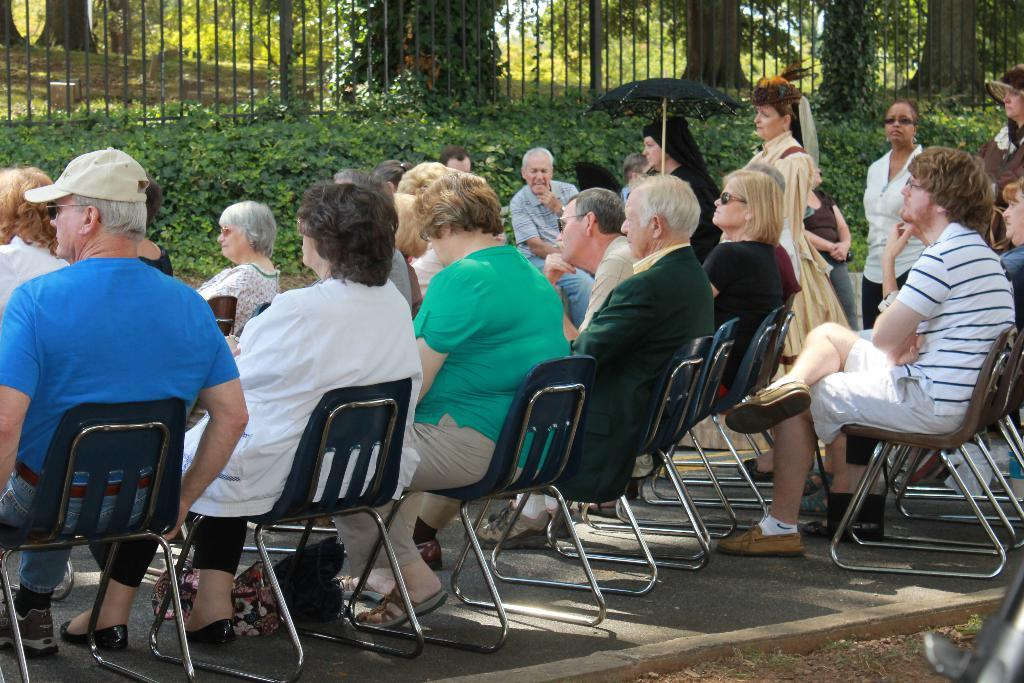How many people are in the image? There is a group of persons in the image. What are the persons doing in the image? The persons are sitting on a chair. What can be seen in the background of the image? There are trees in the background of the image. What type of knife is being used by the persons in the image? There is no knife present in the image. How many bricks are visible in the image? There is no reference to bricks in the image. 